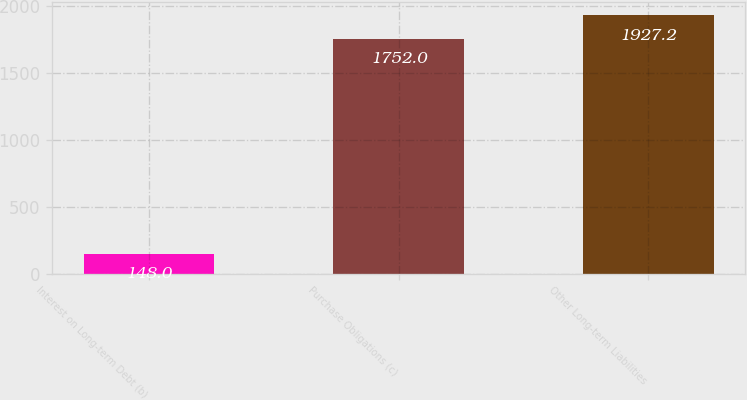Convert chart to OTSL. <chart><loc_0><loc_0><loc_500><loc_500><bar_chart><fcel>Interest on Long-term Debt (b)<fcel>Purchase Obligations (c)<fcel>Other Long-term Liabilities<nl><fcel>148<fcel>1752<fcel>1927.2<nl></chart> 